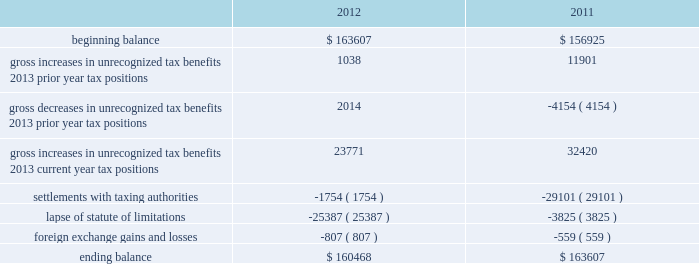Repatriated , the related u.s .
Tax liability may be reduced by any foreign income taxes paid on these earnings .
As of november 30 , 2012 , the cumulative amount of earnings upon which u.s .
Income taxes have not been provided is approximately $ 2.9 billion .
The unrecognized deferred tax liability for these earnings is approximately $ 0.8 billion .
As of november 30 , 2012 , we have u.s .
Net operating loss carryforwards of approximately $ 33.7 million for federal and $ 77.7 million for state .
We also have federal , state and foreign tax credit carryforwards of approximately $ 1.9 million , $ 18.0 million and $ 17.6 million , respectively .
The net operating loss carryforward assets , federal tax credits and foreign tax credits will expire in various years from fiscal 2017 through 2032 .
The state tax credit carryforwards can be carried forward indefinitely .
The net operating loss carryforward assets and certain credits are subject to an annual limitation under internal revenue code section 382 , but are expected to be fully realized .
In addition , we have been tracking certain deferred tax attributes of $ 45.0 million which have not been recorded in the financial statements pursuant to accounting standards related to stock-based compensation .
These amounts are no longer included in our gross or net deferred tax assets .
Pursuant to these standards , the benefit of these deferred tax assets will be recorded to equity if and when they reduce taxes payable .
As of november 30 , 2012 , a valuation allowance of $ 28.2 million has been established for certain deferred tax assets related to the impairment of investments and certain foreign assets .
For fiscal 2012 , the total change in the valuation allowance was $ 23.0 million , of which $ 2.1 million was recorded as a tax benefit through the income statement .
Accounting for uncertainty in income taxes during fiscal 2012 and 2011 , our aggregate changes in our total gross amount of unrecognized tax benefits are summarized as follows ( in thousands ) : .
As of november 30 , 2012 , the combined amount of accrued interest and penalties related to tax positions taken on our tax returns and included in non-current income taxes payable was approximately $ 12.5 million .
We file income tax returns in the u.s .
On a federal basis and in many u.s .
State and foreign jurisdictions .
We are subject to the continual examination of our income tax returns by the irs and other domestic and foreign tax authorities .
Our major tax jurisdictions are the u.s. , ireland and california .
For california , ireland and the u.s. , the earliest fiscal years open for examination are 2005 , 2006 and 2008 , respectively .
We regularly assess the likelihood of outcomes resulting from these examinations to determine the adequacy of our provision for income taxes and have reserved for potential adjustments that may result from the current examinations .
We believe such estimates to be reasonable ; however , there can be no assurance that the final determination of any of these examinations will not have an adverse effect on our operating results and financial position .
In august 2011 , a canadian income tax examination covering our fiscal years 2005 through 2008 was completed .
Our accrued tax and interest related to these years was approximately $ 35 million and was previously reported in long-term income taxes payable .
We reclassified approximately $ 17 million to short-term income taxes payable and decreased deferred tax assets by approximately $ 18 million in conjunction with the aforementioned resolution .
The timing of the resolution of income tax examinations is highly uncertain as are the amounts and timing of tax payments that are part of any audit settlement process .
These events could cause large fluctuations in the balance sheet classification of current and non-current assets and liabilities .
The company believes that before the end of fiscal 2013 , it is reasonably possible table of contents adobe systems incorporated notes to consolidated financial statements ( continued ) .
In millions , what as the change in gross increases in unrecognized tax benefits 2013 prior year tax positions between 2012 and 2011? 
Computations: (11901 - 1038)
Answer: 10863.0. 